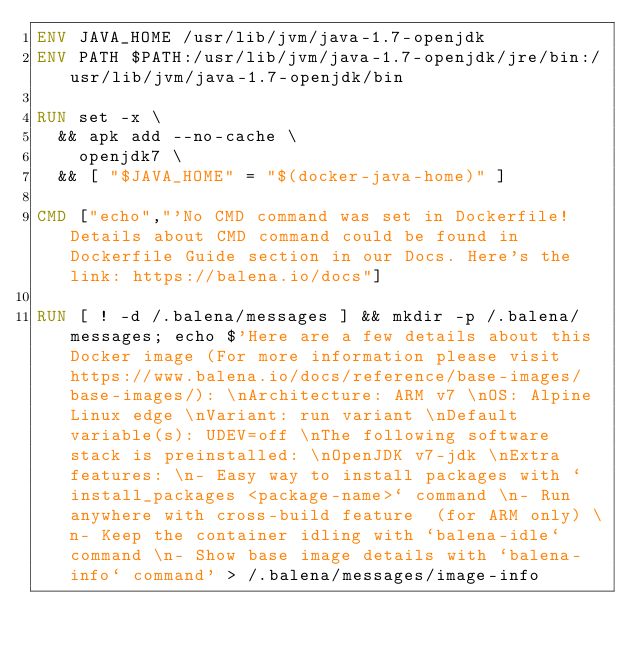<code> <loc_0><loc_0><loc_500><loc_500><_Dockerfile_>ENV JAVA_HOME /usr/lib/jvm/java-1.7-openjdk
ENV PATH $PATH:/usr/lib/jvm/java-1.7-openjdk/jre/bin:/usr/lib/jvm/java-1.7-openjdk/bin

RUN set -x \
	&& apk add --no-cache \
		openjdk7 \
	&& [ "$JAVA_HOME" = "$(docker-java-home)" ]

CMD ["echo","'No CMD command was set in Dockerfile! Details about CMD command could be found in Dockerfile Guide section in our Docs. Here's the link: https://balena.io/docs"]

RUN [ ! -d /.balena/messages ] && mkdir -p /.balena/messages; echo $'Here are a few details about this Docker image (For more information please visit https://www.balena.io/docs/reference/base-images/base-images/): \nArchitecture: ARM v7 \nOS: Alpine Linux edge \nVariant: run variant \nDefault variable(s): UDEV=off \nThe following software stack is preinstalled: \nOpenJDK v7-jdk \nExtra features: \n- Easy way to install packages with `install_packages <package-name>` command \n- Run anywhere with cross-build feature  (for ARM only) \n- Keep the container idling with `balena-idle` command \n- Show base image details with `balena-info` command' > /.balena/messages/image-info</code> 